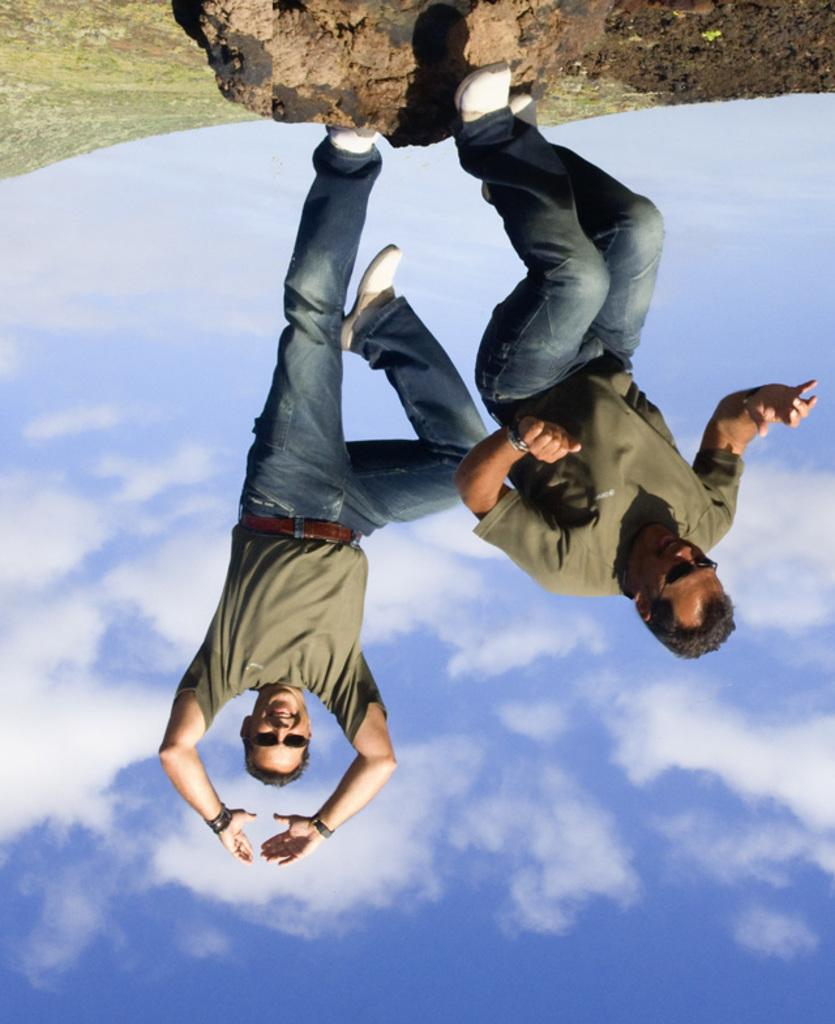How many people are in the image? There are two persons in the image. What are the two persons doing in the image? The two persons are standing on a rock. What can be seen in the background of the image? The sky is visible in the background of the image. What type of drink is being offered to the person standing on the rock? There is no drink present in the image, and therefore no such offering can be observed. 